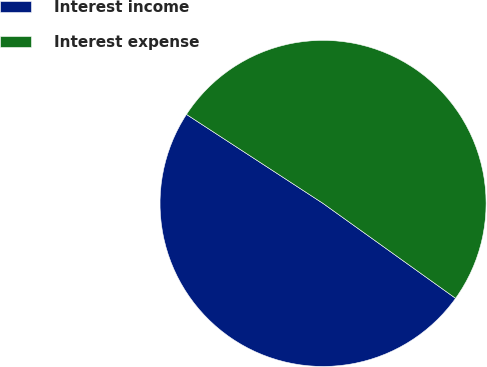Convert chart. <chart><loc_0><loc_0><loc_500><loc_500><pie_chart><fcel>Interest income<fcel>Interest expense<nl><fcel>49.3%<fcel>50.7%<nl></chart> 